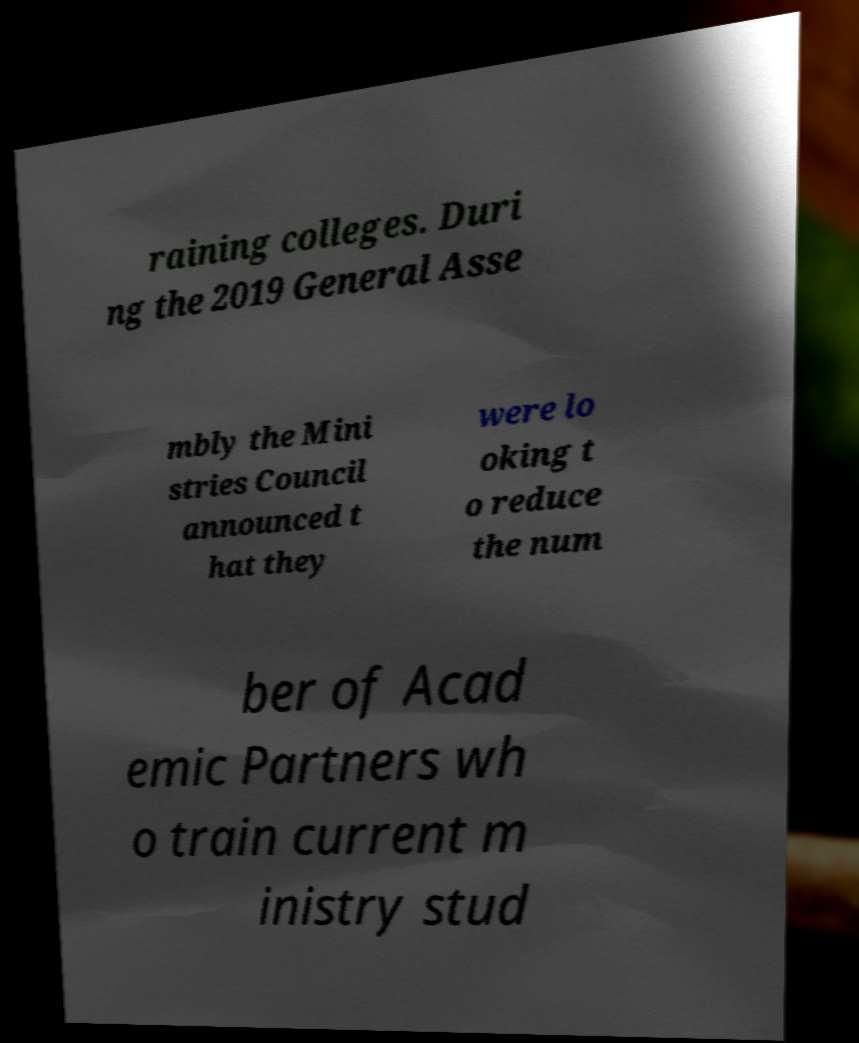Could you assist in decoding the text presented in this image and type it out clearly? raining colleges. Duri ng the 2019 General Asse mbly the Mini stries Council announced t hat they were lo oking t o reduce the num ber of Acad emic Partners wh o train current m inistry stud 